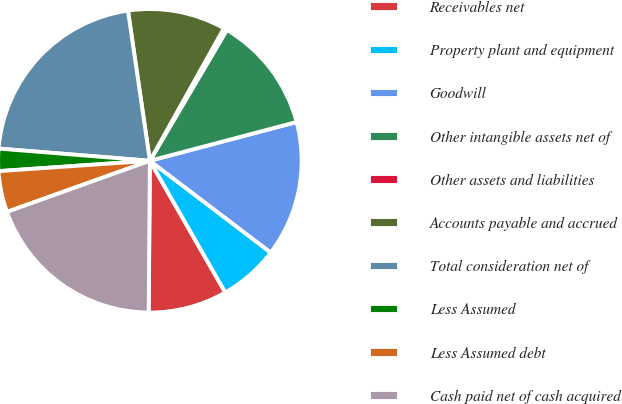Convert chart. <chart><loc_0><loc_0><loc_500><loc_500><pie_chart><fcel>Receivables net<fcel>Property plant and equipment<fcel>Goodwill<fcel>Other intangible assets net of<fcel>Other assets and liabilities<fcel>Accounts payable and accrued<fcel>Total consideration net of<fcel>Less Assumed<fcel>Less Assumed debt<fcel>Cash paid net of cash acquired<nl><fcel>8.4%<fcel>6.39%<fcel>14.44%<fcel>12.42%<fcel>0.36%<fcel>10.41%<fcel>21.41%<fcel>2.37%<fcel>4.38%<fcel>19.4%<nl></chart> 